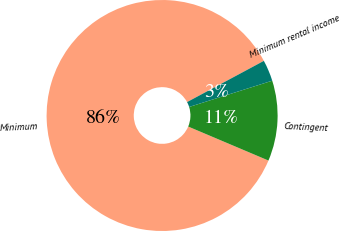Convert chart to OTSL. <chart><loc_0><loc_0><loc_500><loc_500><pie_chart><fcel>Minimum<fcel>Contingent<fcel>Minimum rental income<nl><fcel>85.79%<fcel>11.25%<fcel>2.97%<nl></chart> 